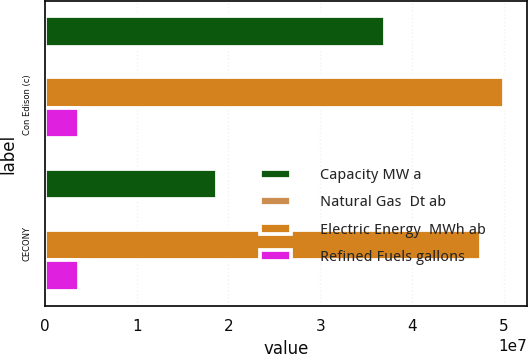Convert chart to OTSL. <chart><loc_0><loc_0><loc_500><loc_500><stacked_bar_chart><ecel><fcel>Con Edison (c)<fcel>CECONY<nl><fcel>Capacity MW a<fcel>3.70363e+07<fcel>1.8742e+07<nl><fcel>Natural Gas  Dt ab<fcel>21174<fcel>12000<nl><fcel>Electric Energy  MWh ab<fcel>5.00528e+07<fcel>4.754e+07<nl><fcel>Refined Fuels gallons<fcel>3.696e+06<fcel>3.696e+06<nl></chart> 